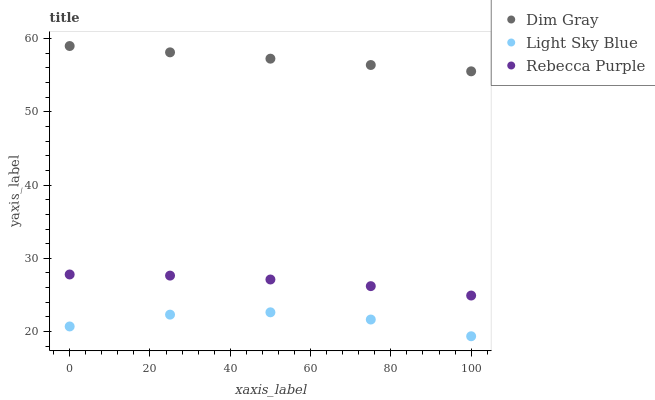Does Light Sky Blue have the minimum area under the curve?
Answer yes or no. Yes. Does Dim Gray have the maximum area under the curve?
Answer yes or no. Yes. Does Rebecca Purple have the minimum area under the curve?
Answer yes or no. No. Does Rebecca Purple have the maximum area under the curve?
Answer yes or no. No. Is Dim Gray the smoothest?
Answer yes or no. Yes. Is Light Sky Blue the roughest?
Answer yes or no. Yes. Is Rebecca Purple the smoothest?
Answer yes or no. No. Is Rebecca Purple the roughest?
Answer yes or no. No. Does Light Sky Blue have the lowest value?
Answer yes or no. Yes. Does Rebecca Purple have the lowest value?
Answer yes or no. No. Does Dim Gray have the highest value?
Answer yes or no. Yes. Does Rebecca Purple have the highest value?
Answer yes or no. No. Is Rebecca Purple less than Dim Gray?
Answer yes or no. Yes. Is Rebecca Purple greater than Light Sky Blue?
Answer yes or no. Yes. Does Rebecca Purple intersect Dim Gray?
Answer yes or no. No. 